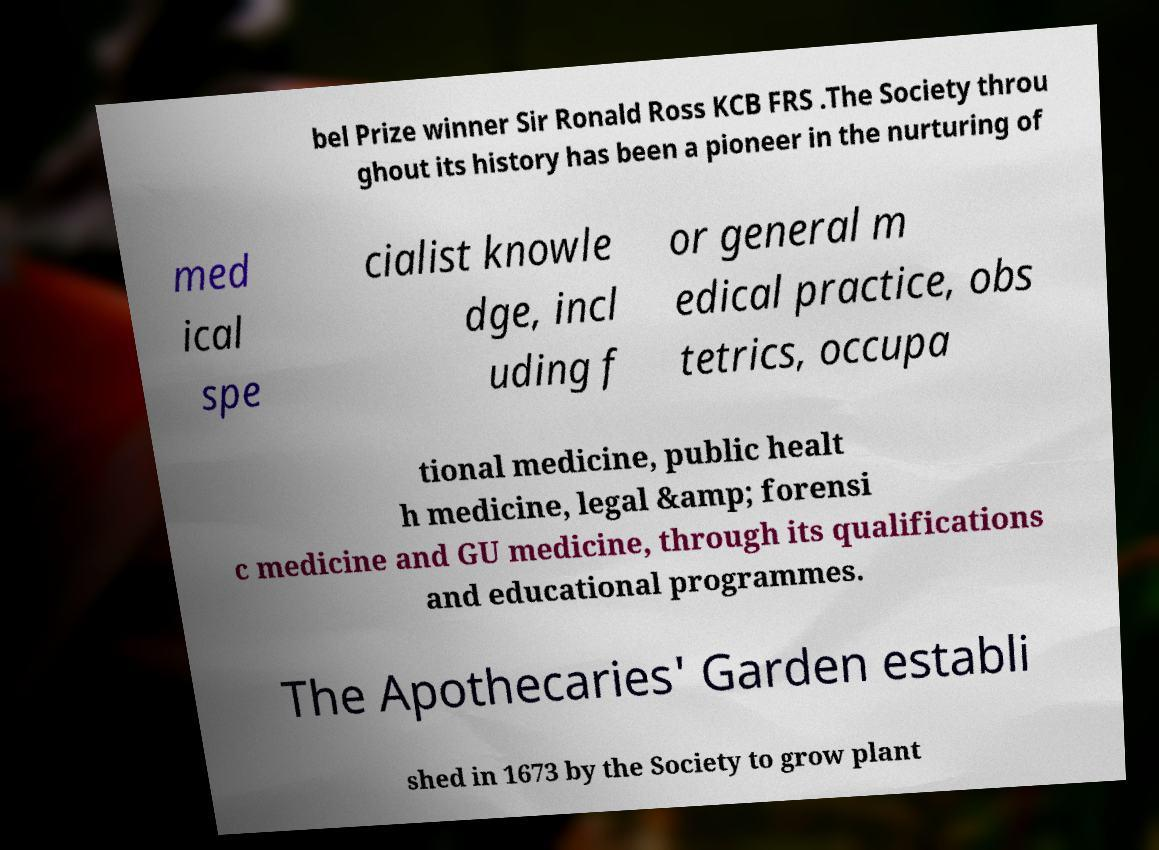What messages or text are displayed in this image? I need them in a readable, typed format. bel Prize winner Sir Ronald Ross KCB FRS .The Society throu ghout its history has been a pioneer in the nurturing of med ical spe cialist knowle dge, incl uding f or general m edical practice, obs tetrics, occupa tional medicine, public healt h medicine, legal &amp; forensi c medicine and GU medicine, through its qualifications and educational programmes. The Apothecaries' Garden establi shed in 1673 by the Society to grow plant 